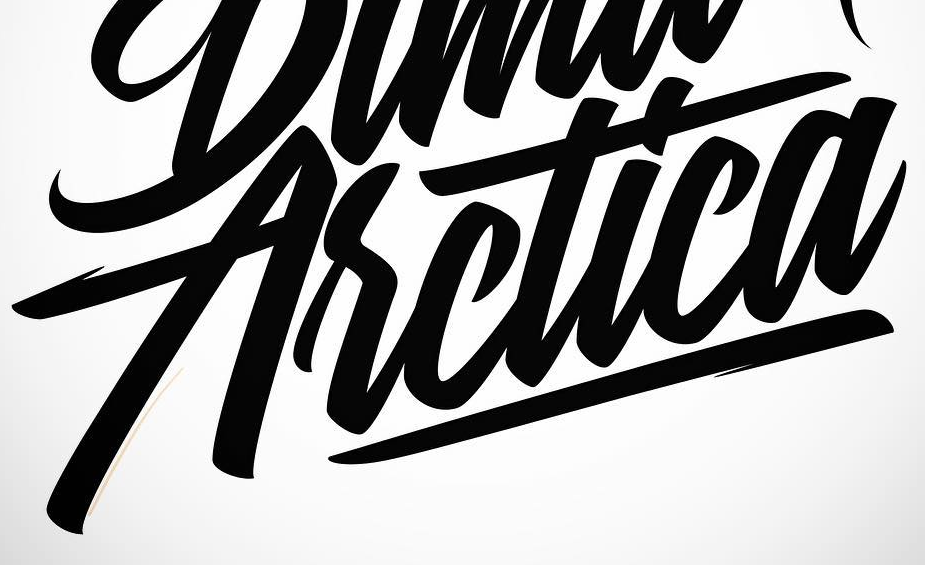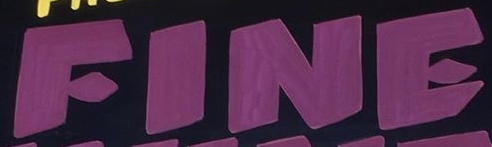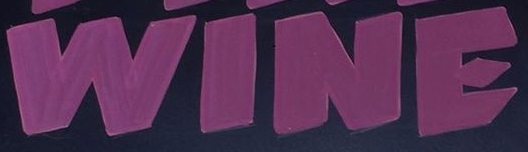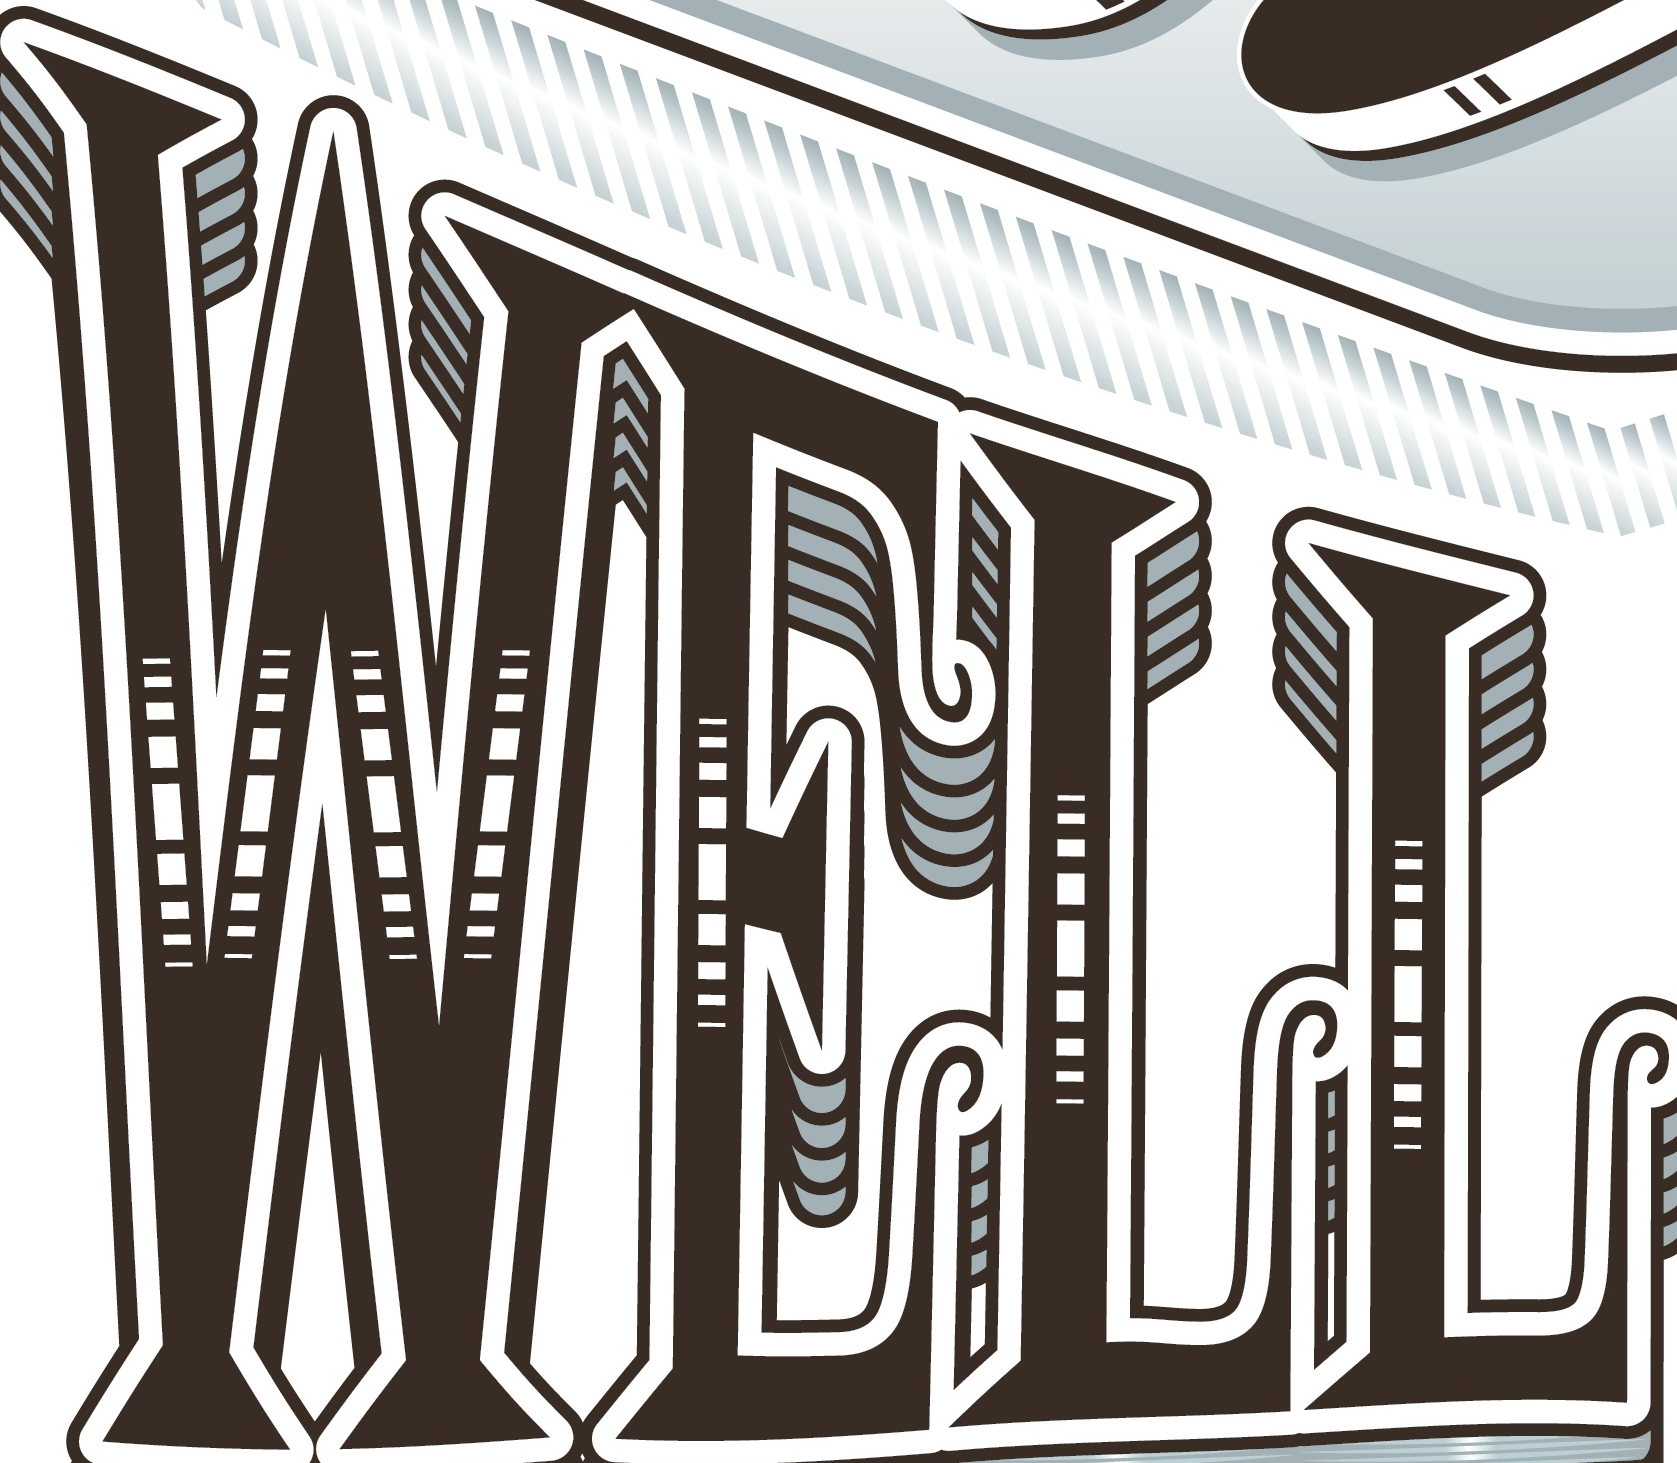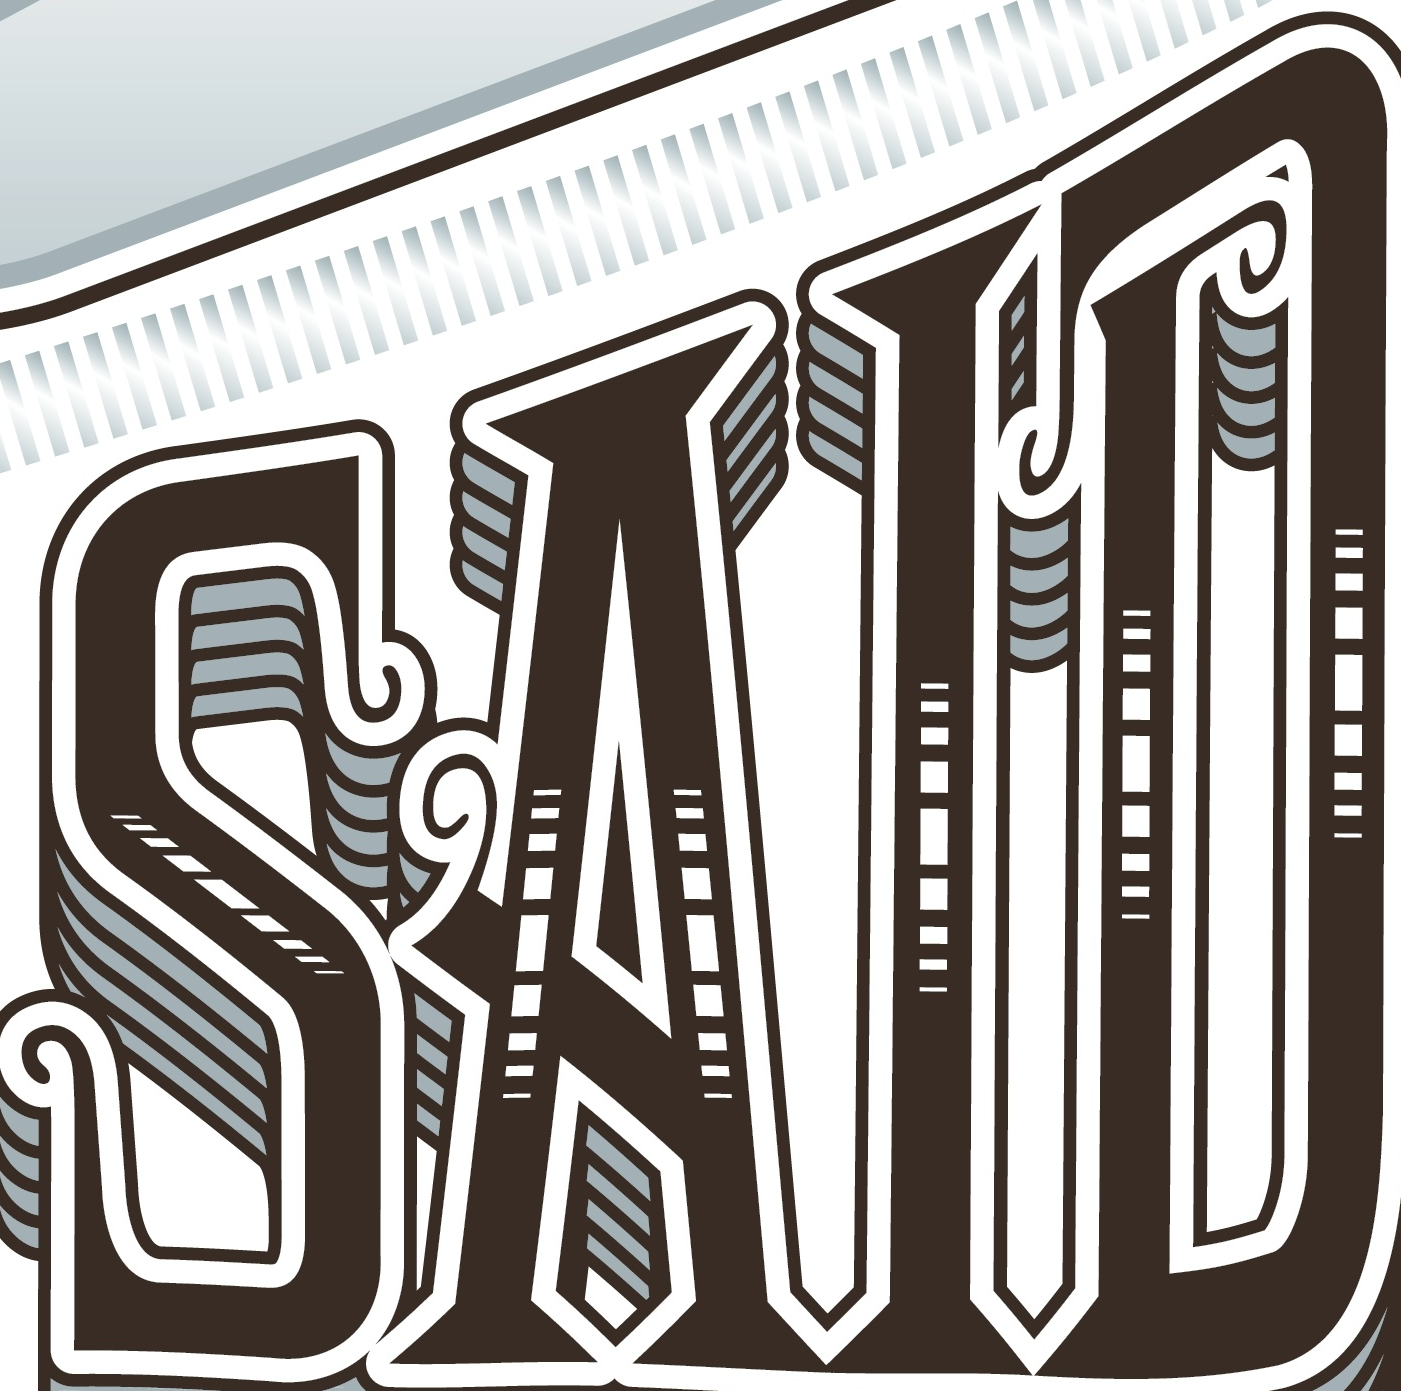What words can you see in these images in sequence, separated by a semicolon? Asctica; FINE; WINE; WELL; SAID 